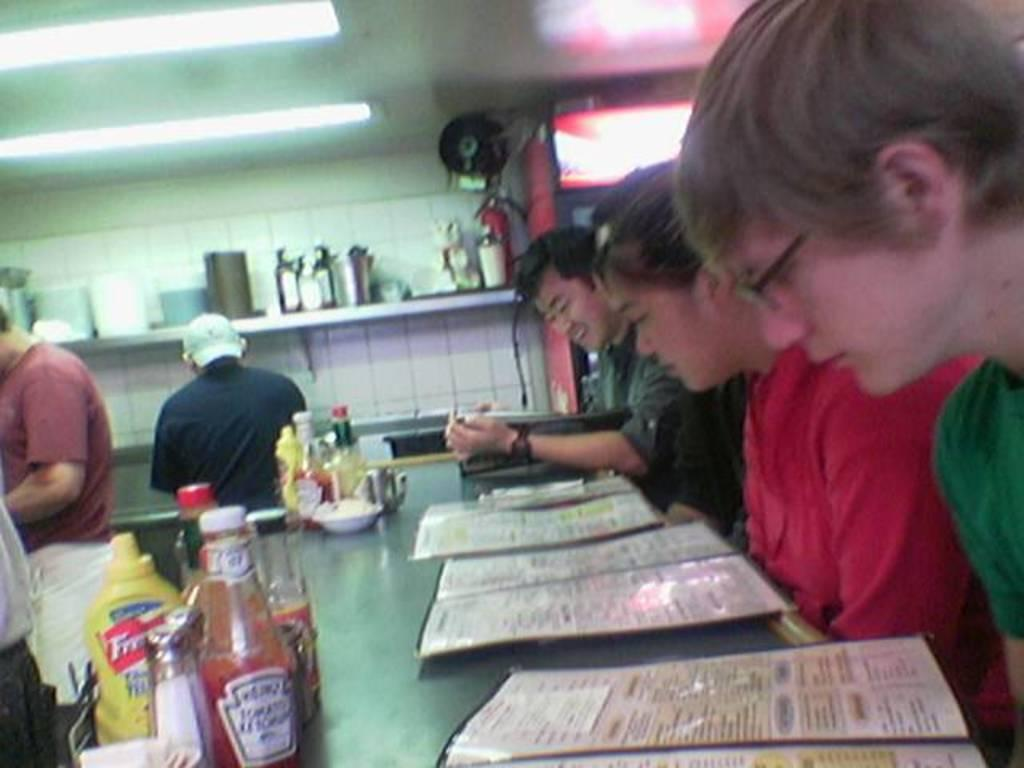How many people are in the image? There is a group of people in the image. What are some of the people in the image doing? Some people are standing. What items can be seen on a table in the image? There are bottles, a bowl, and menu cards present in the image. What can be seen illuminating the scene in the image? Lights are visible in the image. What is located in the background of the image? There are objects on a shelf in the background of the image. What is the income of the person standing next to the stove in the image? There is no stove present in the image, and therefore no information about the person's income can be determined. 